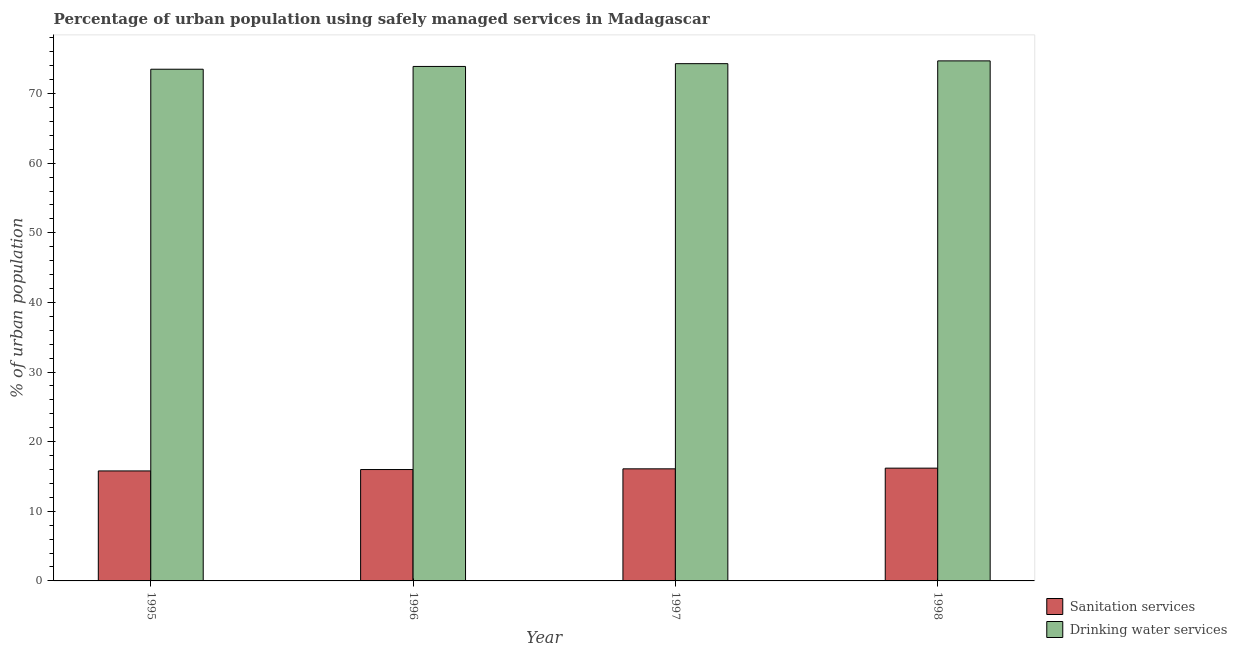How many different coloured bars are there?
Your response must be concise. 2. How many groups of bars are there?
Give a very brief answer. 4. Are the number of bars on each tick of the X-axis equal?
Your answer should be compact. Yes. How many bars are there on the 3rd tick from the left?
Your response must be concise. 2. How many bars are there on the 2nd tick from the right?
Give a very brief answer. 2. In how many cases, is the number of bars for a given year not equal to the number of legend labels?
Offer a terse response. 0. Across all years, what is the maximum percentage of urban population who used drinking water services?
Make the answer very short. 74.7. Across all years, what is the minimum percentage of urban population who used sanitation services?
Offer a terse response. 15.8. In which year was the percentage of urban population who used sanitation services minimum?
Ensure brevity in your answer.  1995. What is the total percentage of urban population who used sanitation services in the graph?
Provide a succinct answer. 64.1. What is the difference between the percentage of urban population who used sanitation services in 1995 and that in 1998?
Keep it short and to the point. -0.4. What is the difference between the percentage of urban population who used drinking water services in 1995 and the percentage of urban population who used sanitation services in 1998?
Provide a succinct answer. -1.2. What is the average percentage of urban population who used drinking water services per year?
Offer a terse response. 74.1. What is the ratio of the percentage of urban population who used sanitation services in 1997 to that in 1998?
Your answer should be compact. 0.99. Is the percentage of urban population who used sanitation services in 1997 less than that in 1998?
Provide a succinct answer. Yes. Is the difference between the percentage of urban population who used drinking water services in 1995 and 1997 greater than the difference between the percentage of urban population who used sanitation services in 1995 and 1997?
Keep it short and to the point. No. What is the difference between the highest and the second highest percentage of urban population who used sanitation services?
Make the answer very short. 0.1. What is the difference between the highest and the lowest percentage of urban population who used sanitation services?
Offer a terse response. 0.4. In how many years, is the percentage of urban population who used drinking water services greater than the average percentage of urban population who used drinking water services taken over all years?
Your answer should be compact. 2. What does the 1st bar from the left in 1995 represents?
Keep it short and to the point. Sanitation services. What does the 2nd bar from the right in 1997 represents?
Your response must be concise. Sanitation services. How many years are there in the graph?
Keep it short and to the point. 4. Are the values on the major ticks of Y-axis written in scientific E-notation?
Keep it short and to the point. No. Where does the legend appear in the graph?
Your answer should be compact. Bottom right. How many legend labels are there?
Your answer should be very brief. 2. How are the legend labels stacked?
Offer a terse response. Vertical. What is the title of the graph?
Your answer should be compact. Percentage of urban population using safely managed services in Madagascar. Does "UN agencies" appear as one of the legend labels in the graph?
Give a very brief answer. No. What is the label or title of the Y-axis?
Offer a terse response. % of urban population. What is the % of urban population of Drinking water services in 1995?
Your response must be concise. 73.5. What is the % of urban population in Drinking water services in 1996?
Offer a terse response. 73.9. What is the % of urban population of Drinking water services in 1997?
Your answer should be compact. 74.3. What is the % of urban population in Sanitation services in 1998?
Give a very brief answer. 16.2. What is the % of urban population of Drinking water services in 1998?
Offer a very short reply. 74.7. Across all years, what is the maximum % of urban population of Drinking water services?
Keep it short and to the point. 74.7. Across all years, what is the minimum % of urban population of Sanitation services?
Provide a short and direct response. 15.8. Across all years, what is the minimum % of urban population of Drinking water services?
Ensure brevity in your answer.  73.5. What is the total % of urban population in Sanitation services in the graph?
Offer a very short reply. 64.1. What is the total % of urban population in Drinking water services in the graph?
Make the answer very short. 296.4. What is the difference between the % of urban population in Drinking water services in 1995 and that in 1996?
Keep it short and to the point. -0.4. What is the difference between the % of urban population in Sanitation services in 1995 and that in 1998?
Ensure brevity in your answer.  -0.4. What is the difference between the % of urban population of Drinking water services in 1995 and that in 1998?
Give a very brief answer. -1.2. What is the difference between the % of urban population of Drinking water services in 1996 and that in 1998?
Offer a terse response. -0.8. What is the difference between the % of urban population in Sanitation services in 1997 and that in 1998?
Your answer should be compact. -0.1. What is the difference between the % of urban population in Drinking water services in 1997 and that in 1998?
Provide a short and direct response. -0.4. What is the difference between the % of urban population of Sanitation services in 1995 and the % of urban population of Drinking water services in 1996?
Your response must be concise. -58.1. What is the difference between the % of urban population in Sanitation services in 1995 and the % of urban population in Drinking water services in 1997?
Provide a succinct answer. -58.5. What is the difference between the % of urban population in Sanitation services in 1995 and the % of urban population in Drinking water services in 1998?
Offer a terse response. -58.9. What is the difference between the % of urban population in Sanitation services in 1996 and the % of urban population in Drinking water services in 1997?
Your answer should be compact. -58.3. What is the difference between the % of urban population in Sanitation services in 1996 and the % of urban population in Drinking water services in 1998?
Keep it short and to the point. -58.7. What is the difference between the % of urban population in Sanitation services in 1997 and the % of urban population in Drinking water services in 1998?
Keep it short and to the point. -58.6. What is the average % of urban population in Sanitation services per year?
Your answer should be compact. 16.02. What is the average % of urban population in Drinking water services per year?
Make the answer very short. 74.1. In the year 1995, what is the difference between the % of urban population in Sanitation services and % of urban population in Drinking water services?
Your response must be concise. -57.7. In the year 1996, what is the difference between the % of urban population of Sanitation services and % of urban population of Drinking water services?
Ensure brevity in your answer.  -57.9. In the year 1997, what is the difference between the % of urban population in Sanitation services and % of urban population in Drinking water services?
Offer a very short reply. -58.2. In the year 1998, what is the difference between the % of urban population in Sanitation services and % of urban population in Drinking water services?
Your answer should be very brief. -58.5. What is the ratio of the % of urban population of Sanitation services in 1995 to that in 1996?
Provide a succinct answer. 0.99. What is the ratio of the % of urban population of Drinking water services in 1995 to that in 1996?
Provide a short and direct response. 0.99. What is the ratio of the % of urban population of Sanitation services in 1995 to that in 1997?
Offer a terse response. 0.98. What is the ratio of the % of urban population in Drinking water services in 1995 to that in 1997?
Provide a succinct answer. 0.99. What is the ratio of the % of urban population of Sanitation services in 1995 to that in 1998?
Keep it short and to the point. 0.98. What is the ratio of the % of urban population of Drinking water services in 1995 to that in 1998?
Ensure brevity in your answer.  0.98. What is the ratio of the % of urban population in Drinking water services in 1996 to that in 1997?
Give a very brief answer. 0.99. What is the ratio of the % of urban population of Sanitation services in 1996 to that in 1998?
Ensure brevity in your answer.  0.99. What is the ratio of the % of urban population in Drinking water services in 1996 to that in 1998?
Keep it short and to the point. 0.99. What is the ratio of the % of urban population in Sanitation services in 1997 to that in 1998?
Keep it short and to the point. 0.99. What is the ratio of the % of urban population of Drinking water services in 1997 to that in 1998?
Your answer should be compact. 0.99. What is the difference between the highest and the second highest % of urban population in Sanitation services?
Give a very brief answer. 0.1. What is the difference between the highest and the second highest % of urban population in Drinking water services?
Ensure brevity in your answer.  0.4. What is the difference between the highest and the lowest % of urban population in Drinking water services?
Give a very brief answer. 1.2. 